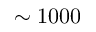Convert formula to latex. <formula><loc_0><loc_0><loc_500><loc_500>\sim 1 0 0 0</formula> 